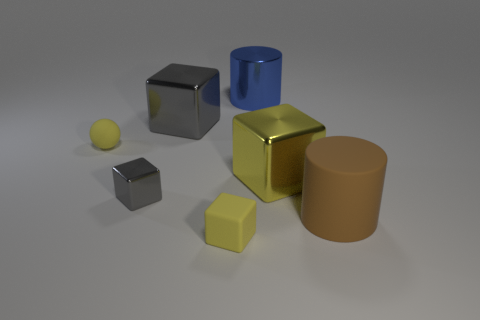The metallic object that is the same color as the rubber cube is what size?
Make the answer very short. Large. How many blue metallic cylinders are on the right side of the metallic cube that is in front of the cube right of the large blue cylinder?
Your answer should be compact. 1. What size is the other thing that is the same shape as the brown rubber object?
Make the answer very short. Large. Is the material of the gray thing in front of the yellow matte ball the same as the big gray block?
Provide a short and direct response. Yes. There is another shiny object that is the same shape as the big brown thing; what is its color?
Your answer should be very brief. Blue. What number of other objects are the same color as the large metal cylinder?
Your answer should be compact. 0. Does the small yellow object in front of the brown rubber cylinder have the same shape as the large metal object in front of the tiny yellow sphere?
Offer a very short reply. Yes. What number of cubes are objects or big yellow things?
Offer a terse response. 4. Is the number of rubber spheres right of the small yellow cube less than the number of tiny red rubber cubes?
Keep it short and to the point. No. How many other things are made of the same material as the large brown object?
Provide a succinct answer. 2. 